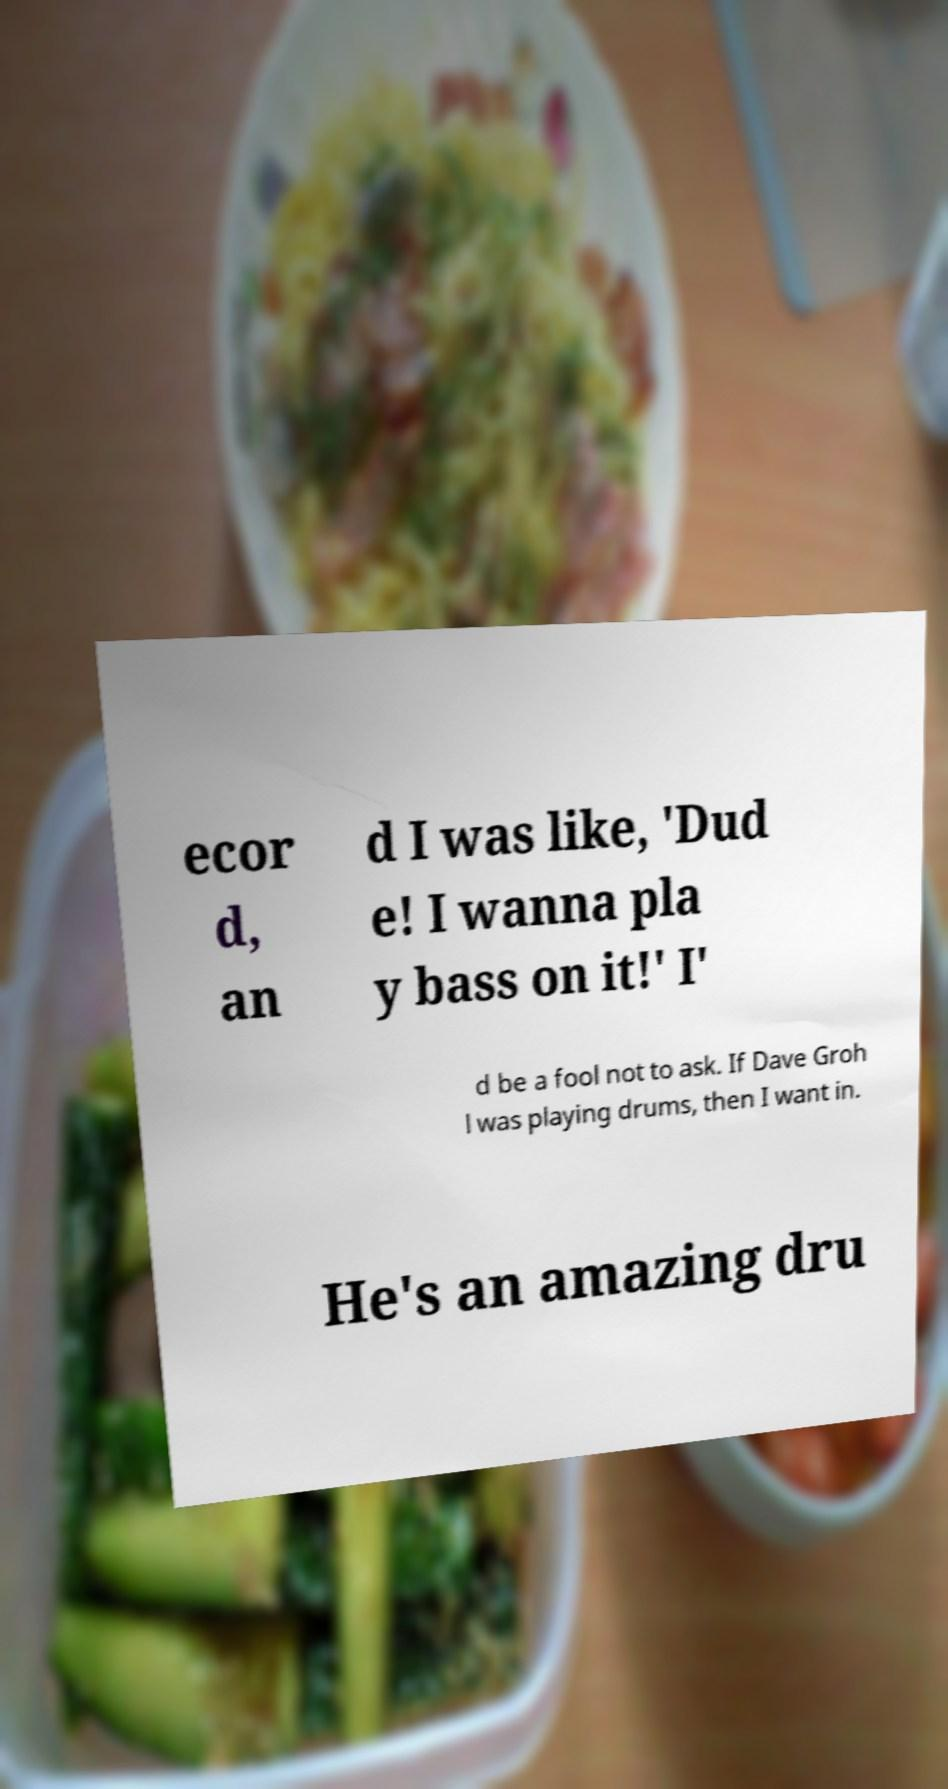Please read and relay the text visible in this image. What does it say? ecor d, an d I was like, 'Dud e! I wanna pla y bass on it!' I' d be a fool not to ask. If Dave Groh l was playing drums, then I want in. He's an amazing dru 